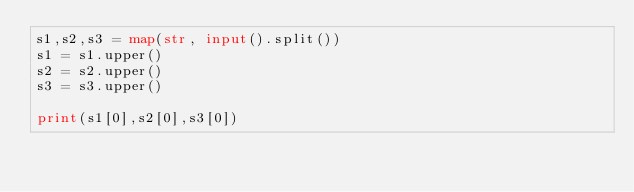Convert code to text. <code><loc_0><loc_0><loc_500><loc_500><_Python_>s1,s2,s3 = map(str, input().split())
s1 = s1.upper()
s2 = s2.upper()
s3 = s3.upper()

print(s1[0],s2[0],s3[0])</code> 